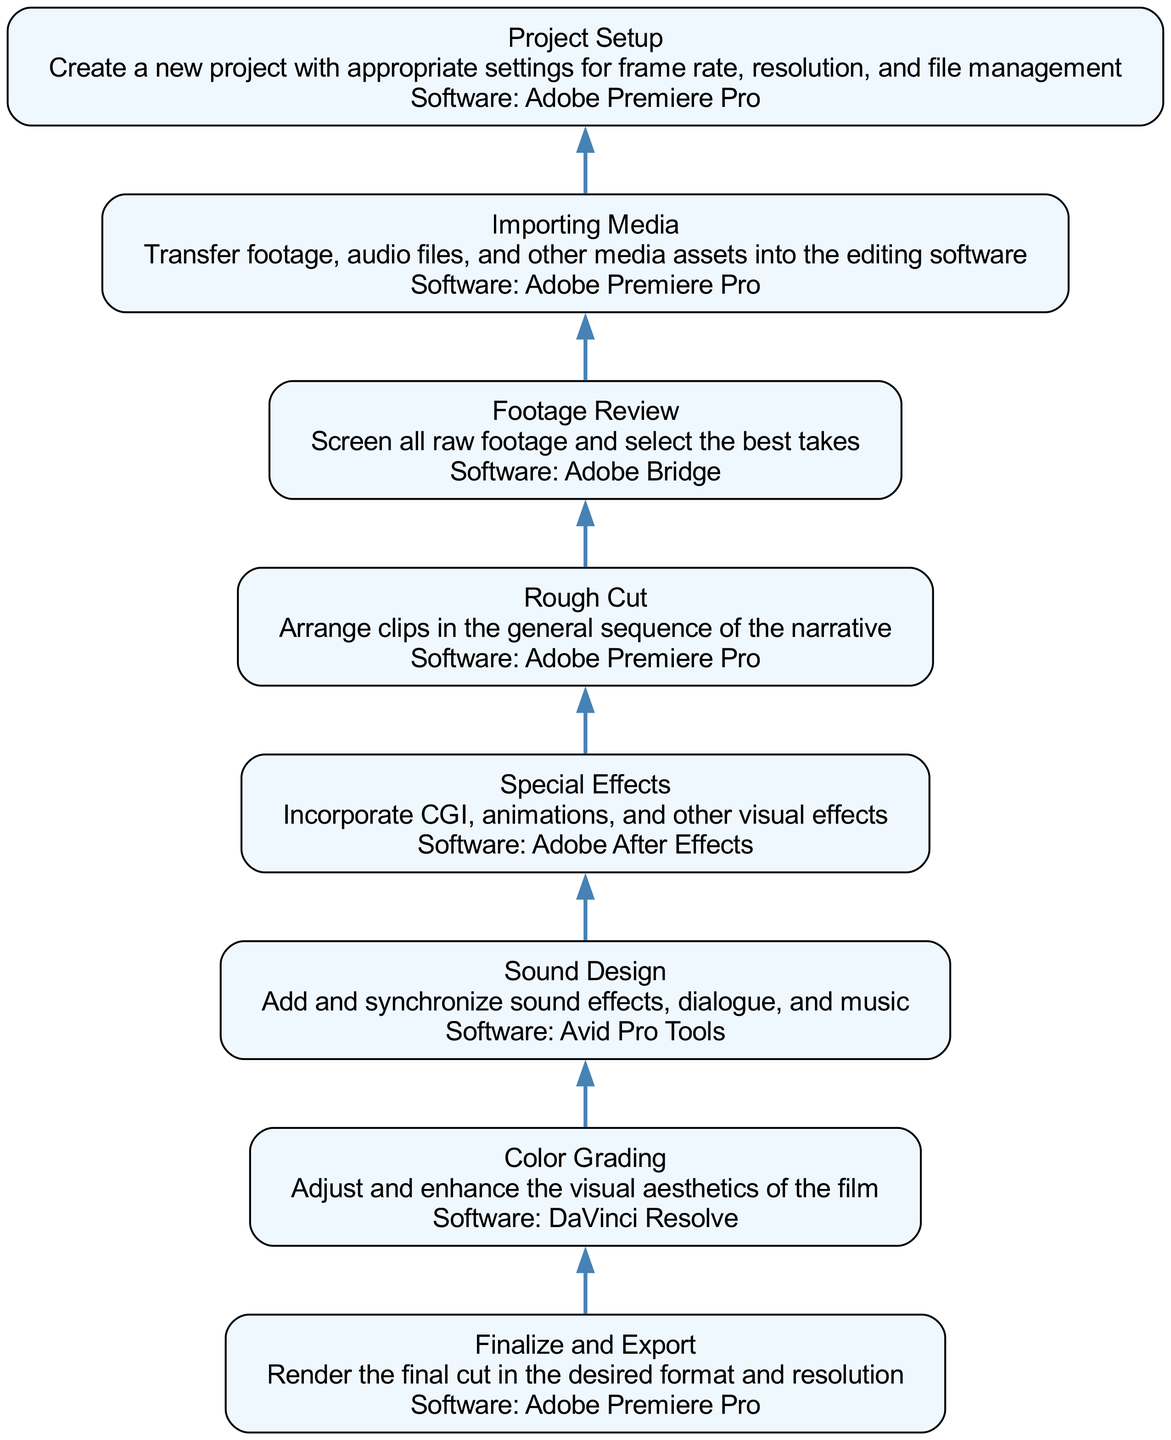What is the first step in the workflow? The workflow starts from the bottom of the diagram, and the first step listed there is "Project Setup".
Answer: Project Setup How many total steps are there in the editing workflow? By counting each node in the diagram from the bottom to the top, we can identify a total of eight steps in the workflow.
Answer: 8 What software is used for "Color Grading"? The node for "Color Grading" includes information that specifies the software used for this step, which is "DaVinci Resolve."
Answer: DaVinci Resolve Which step comes directly after "Rough Cut"? To find the step following "Rough Cut," I locate the "Rough Cut" node and look at its direct upward connection in the diagram, which points to the "Sound Design" step.
Answer: Sound Design What task is associated with the software "Adobe After Effects"? By checking the respective node in the diagram, it is clear that "Special Effects" is the task that uses "Adobe After Effects."
Answer: Special Effects What is the main purpose of the "Footage Review" step? The description associated with the "Footage Review" node specifies that the purpose is to "Screen all raw footage and select the best takes."
Answer: Screen all raw footage and select the best takes What are the last two steps in the workflow, from bottom to top? The last two steps can be identified by examining the top nodes in the diagram, which are "Finalize and Export" and "Color Grading."
Answer: Finalize and Export, Color Grading How does "Importing Media" relate to the "Footage Review"? To understand the relationship, I trace from "Importing Media" up to "Footage Review"; importation happens before reviewing the footage, indicating a sequential flow where you must import media prior to reviewing it.
Answer: Importing Media happens before Footage Review 